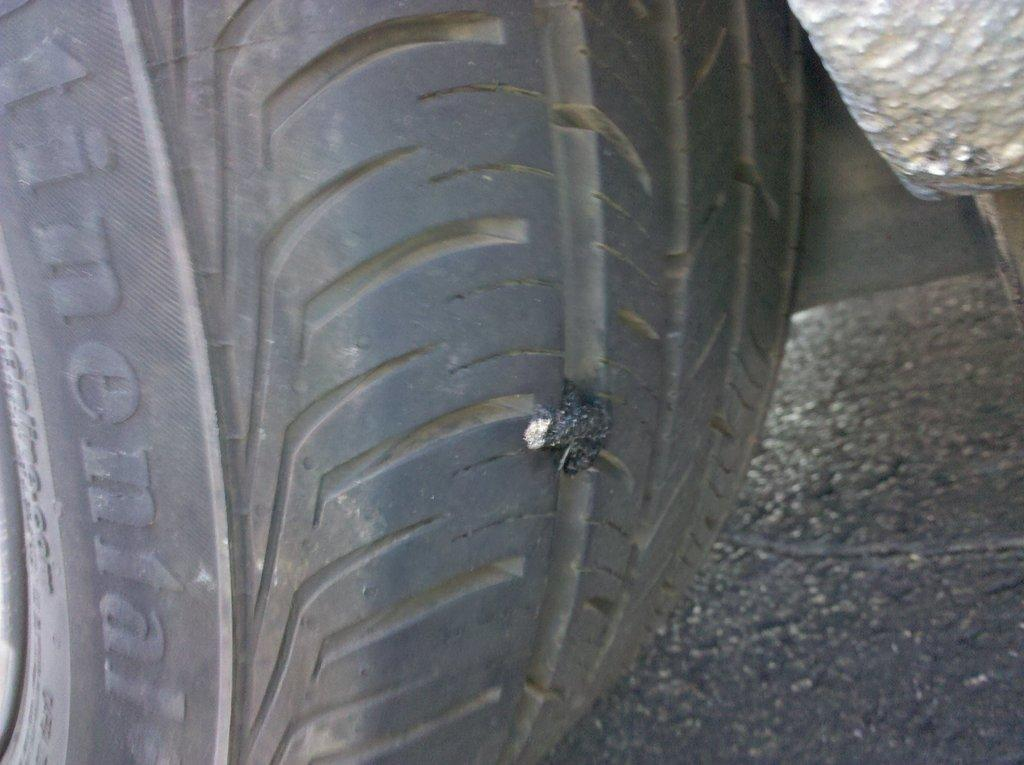What is the main object in the image? There is a black tire in the image. Can you describe any smaller objects attached to the tire? Yes, there is a tiny thing attached to the tire. What type of basketball is being played with the tire in the image? There is no basketball present in the image; it only features a black tire with a tiny thing attached to it. 